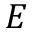Convert formula to latex. <formula><loc_0><loc_0><loc_500><loc_500>E</formula> 